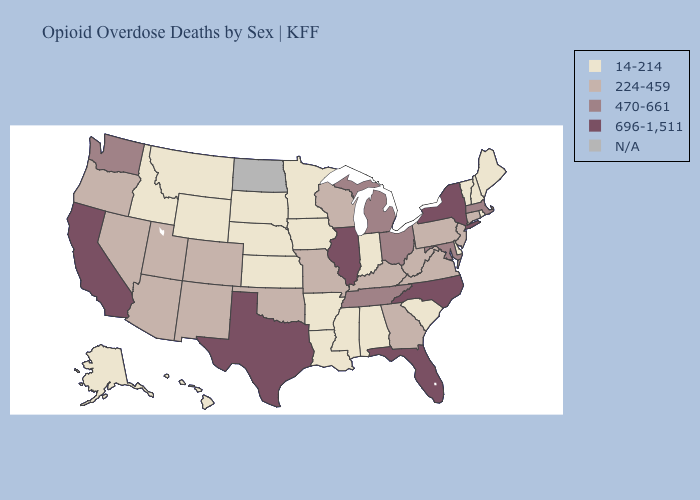Name the states that have a value in the range N/A?
Short answer required. North Dakota. What is the lowest value in the South?
Short answer required. 14-214. Name the states that have a value in the range 696-1,511?
Concise answer only. California, Florida, Illinois, New York, North Carolina, Texas. What is the value of Oklahoma?
Be succinct. 224-459. Does Hawaii have the highest value in the West?
Short answer required. No. What is the value of Arkansas?
Answer briefly. 14-214. Which states have the highest value in the USA?
Be succinct. California, Florida, Illinois, New York, North Carolina, Texas. What is the value of Washington?
Quick response, please. 470-661. Which states have the highest value in the USA?
Concise answer only. California, Florida, Illinois, New York, North Carolina, Texas. Among the states that border South Dakota , which have the lowest value?
Concise answer only. Iowa, Minnesota, Montana, Nebraska, Wyoming. What is the value of Rhode Island?
Be succinct. 14-214. Name the states that have a value in the range 470-661?
Write a very short answer. Maryland, Massachusetts, Michigan, Ohio, Tennessee, Washington. What is the lowest value in the MidWest?
Give a very brief answer. 14-214. What is the value of Montana?
Quick response, please. 14-214. 